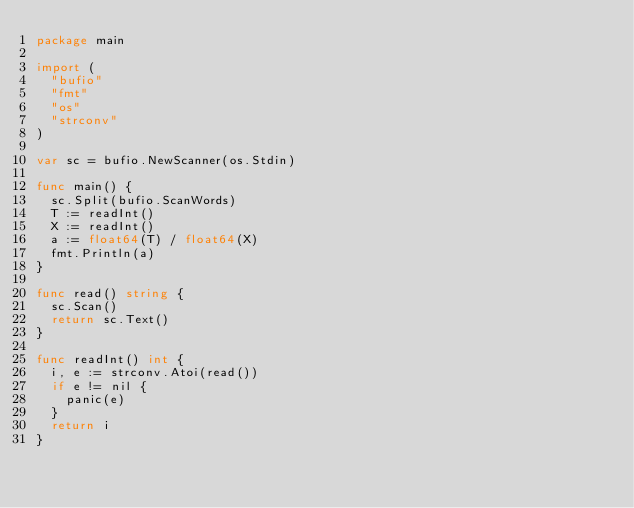<code> <loc_0><loc_0><loc_500><loc_500><_Go_>package main

import (
	"bufio"
	"fmt"
	"os"
	"strconv"
)

var sc = bufio.NewScanner(os.Stdin)

func main() {
	sc.Split(bufio.ScanWords)
	T := readInt()
	X := readInt()
	a := float64(T) / float64(X)
	fmt.Println(a)
}

func read() string {
	sc.Scan()
	return sc.Text()
}

func readInt() int {
	i, e := strconv.Atoi(read())
	if e != nil {
		panic(e)
	}
	return i
}
</code> 